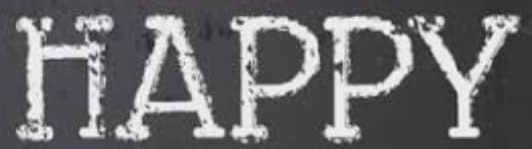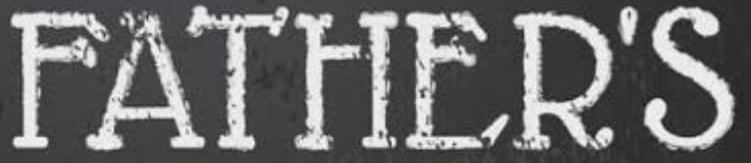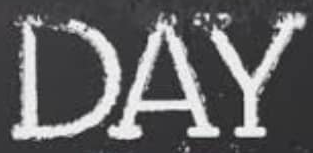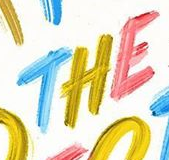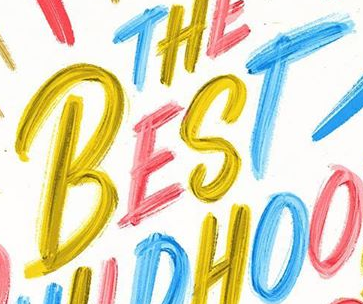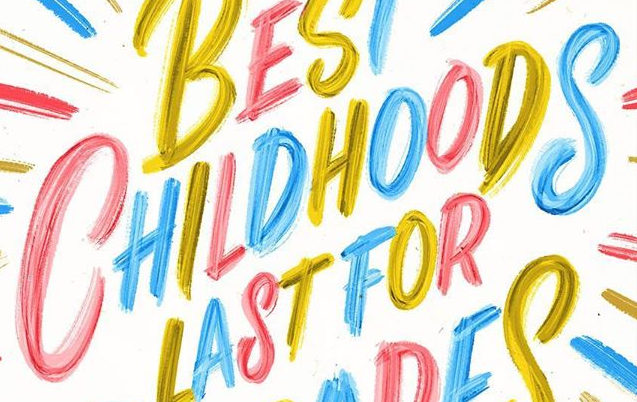What text appears in these images from left to right, separated by a semicolon? HAPPY; FATHER'S; DAY; THE; BEST; CHILDHOODS 